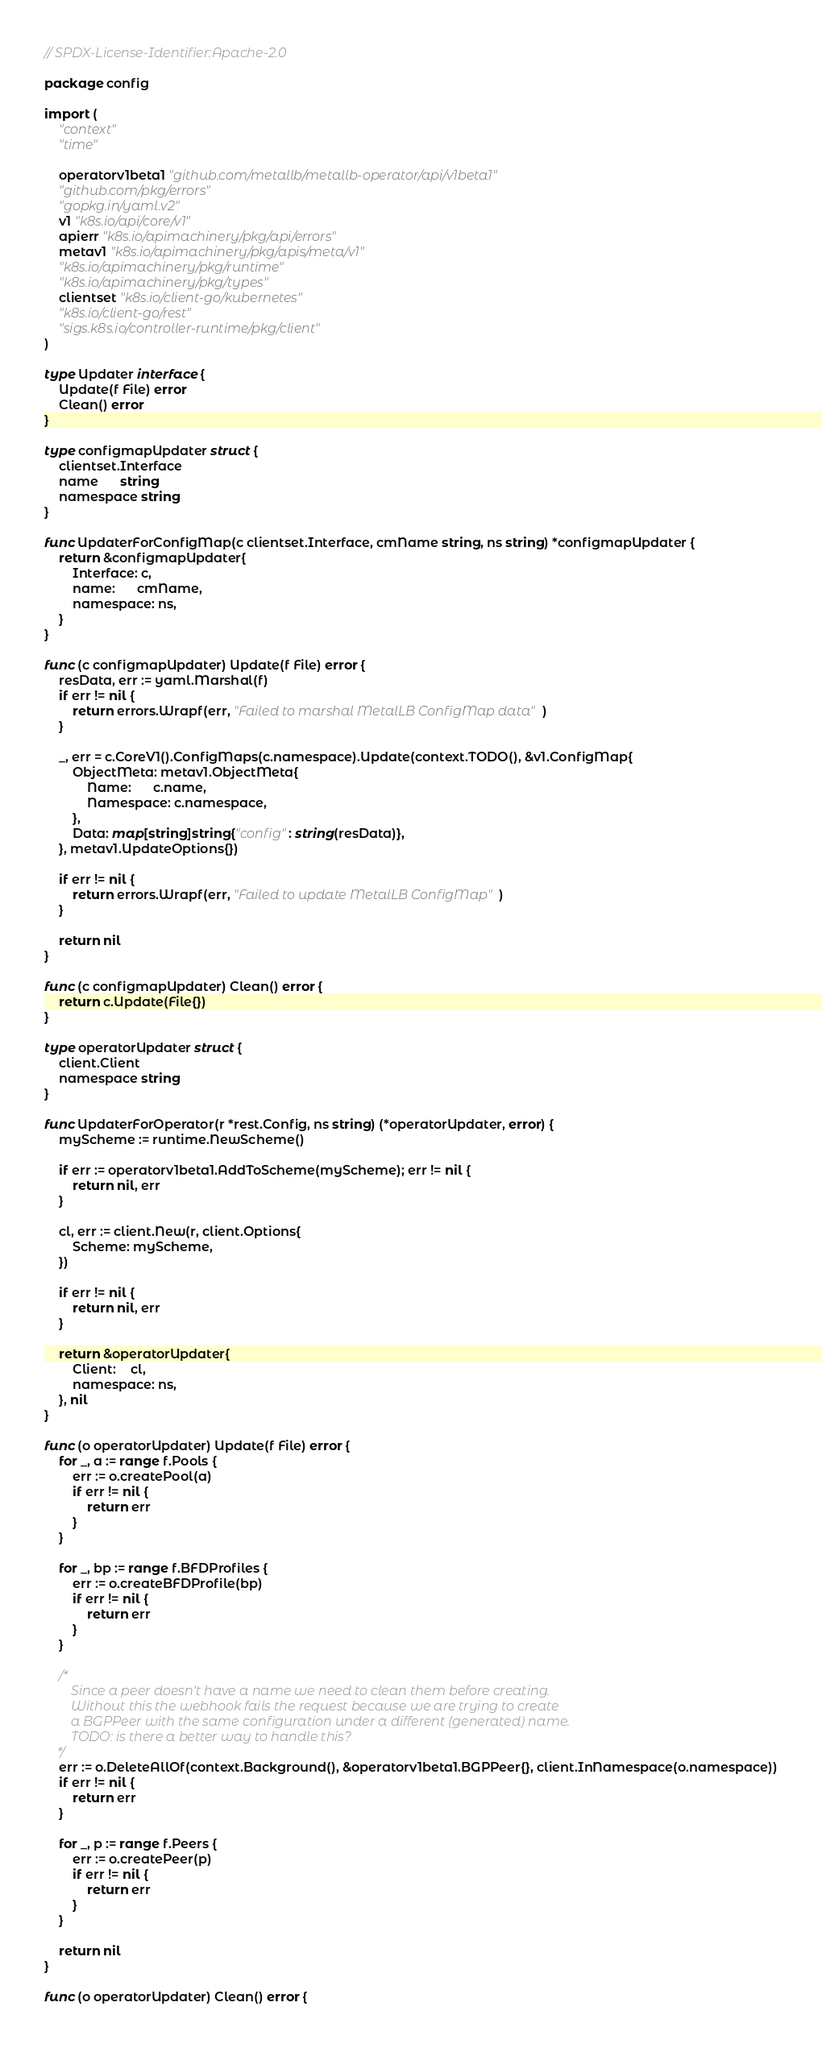<code> <loc_0><loc_0><loc_500><loc_500><_Go_>// SPDX-License-Identifier:Apache-2.0

package config

import (
	"context"
	"time"

	operatorv1beta1 "github.com/metallb/metallb-operator/api/v1beta1"
	"github.com/pkg/errors"
	"gopkg.in/yaml.v2"
	v1 "k8s.io/api/core/v1"
	apierr "k8s.io/apimachinery/pkg/api/errors"
	metav1 "k8s.io/apimachinery/pkg/apis/meta/v1"
	"k8s.io/apimachinery/pkg/runtime"
	"k8s.io/apimachinery/pkg/types"
	clientset "k8s.io/client-go/kubernetes"
	"k8s.io/client-go/rest"
	"sigs.k8s.io/controller-runtime/pkg/client"
)

type Updater interface {
	Update(f File) error
	Clean() error
}

type configmapUpdater struct {
	clientset.Interface
	name      string
	namespace string
}

func UpdaterForConfigMap(c clientset.Interface, cmName string, ns string) *configmapUpdater {
	return &configmapUpdater{
		Interface: c,
		name:      cmName,
		namespace: ns,
	}
}

func (c configmapUpdater) Update(f File) error {
	resData, err := yaml.Marshal(f)
	if err != nil {
		return errors.Wrapf(err, "Failed to marshal MetalLB ConfigMap data")
	}

	_, err = c.CoreV1().ConfigMaps(c.namespace).Update(context.TODO(), &v1.ConfigMap{
		ObjectMeta: metav1.ObjectMeta{
			Name:      c.name,
			Namespace: c.namespace,
		},
		Data: map[string]string{"config": string(resData)},
	}, metav1.UpdateOptions{})

	if err != nil {
		return errors.Wrapf(err, "Failed to update MetalLB ConfigMap")
	}

	return nil
}

func (c configmapUpdater) Clean() error {
	return c.Update(File{})
}

type operatorUpdater struct {
	client.Client
	namespace string
}

func UpdaterForOperator(r *rest.Config, ns string) (*operatorUpdater, error) {
	myScheme := runtime.NewScheme()

	if err := operatorv1beta1.AddToScheme(myScheme); err != nil {
		return nil, err
	}

	cl, err := client.New(r, client.Options{
		Scheme: myScheme,
	})

	if err != nil {
		return nil, err
	}

	return &operatorUpdater{
		Client:    cl,
		namespace: ns,
	}, nil
}

func (o operatorUpdater) Update(f File) error {
	for _, a := range f.Pools {
		err := o.createPool(a)
		if err != nil {
			return err
		}
	}

	for _, bp := range f.BFDProfiles {
		err := o.createBFDProfile(bp)
		if err != nil {
			return err
		}
	}

	/*
		Since a peer doesn't have a name we need to clean them before creating.
		Without this the webhook fails the request because we are trying to create
		a BGPPeer with the same configuration under a different (generated) name.
		TODO: is there a better way to handle this?
	*/
	err := o.DeleteAllOf(context.Background(), &operatorv1beta1.BGPPeer{}, client.InNamespace(o.namespace))
	if err != nil {
		return err
	}

	for _, p := range f.Peers {
		err := o.createPeer(p)
		if err != nil {
			return err
		}
	}

	return nil
}

func (o operatorUpdater) Clean() error {</code> 